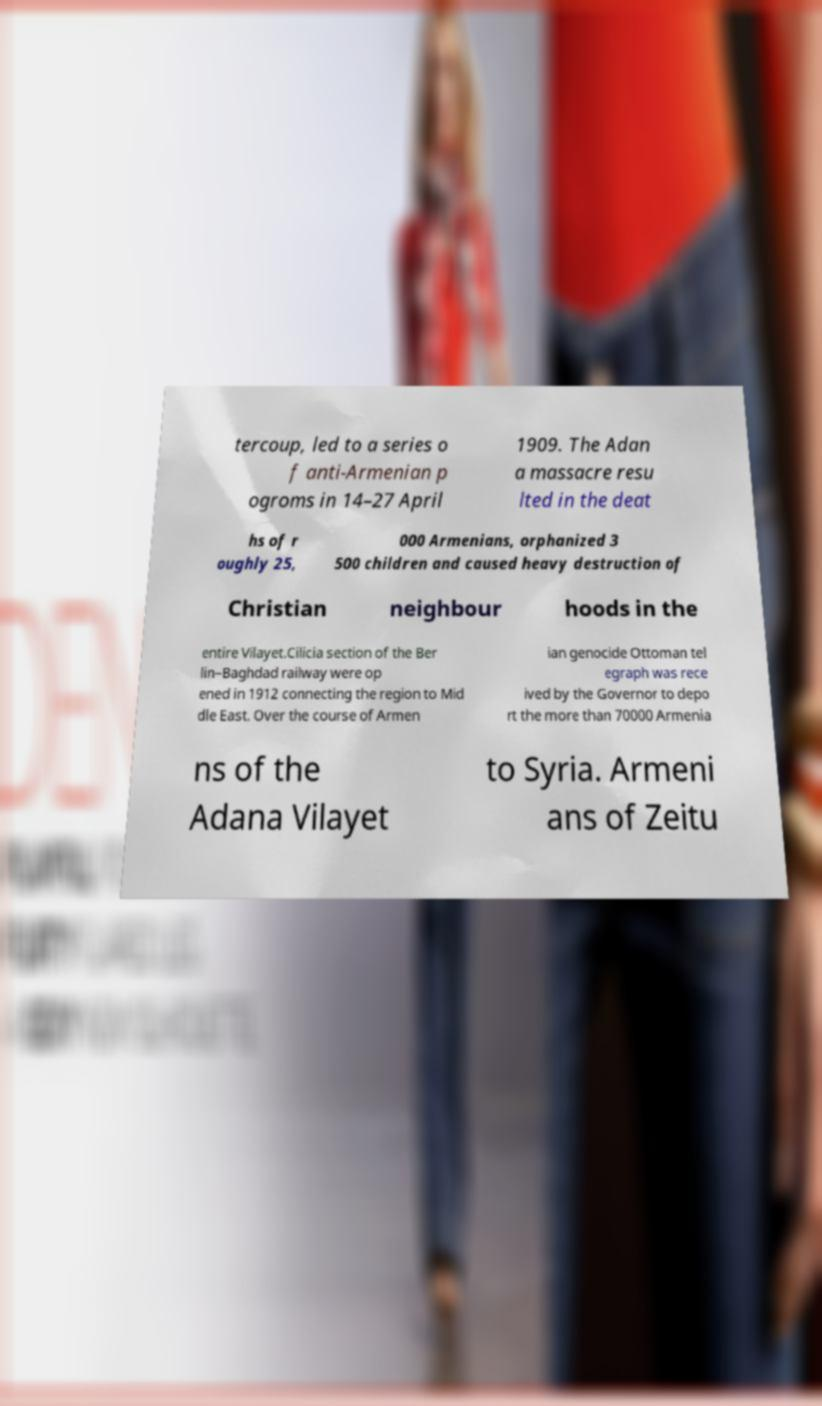For documentation purposes, I need the text within this image transcribed. Could you provide that? tercoup, led to a series o f anti-Armenian p ogroms in 14–27 April 1909. The Adan a massacre resu lted in the deat hs of r oughly 25, 000 Armenians, orphanized 3 500 children and caused heavy destruction of Christian neighbour hoods in the entire Vilayet.Cilicia section of the Ber lin–Baghdad railway were op ened in 1912 connecting the region to Mid dle East. Over the course of Armen ian genocide Ottoman tel egraph was rece ived by the Governor to depo rt the more than 70000 Armenia ns of the Adana Vilayet to Syria. Armeni ans of Zeitu 